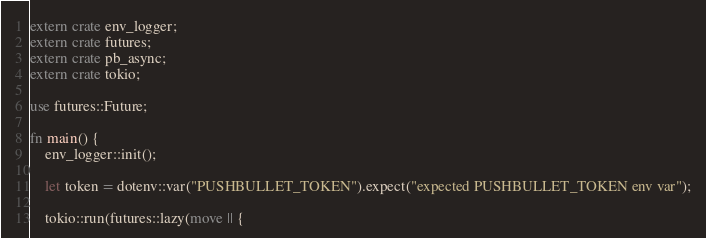Convert code to text. <code><loc_0><loc_0><loc_500><loc_500><_Rust_>extern crate env_logger;
extern crate futures;
extern crate pb_async;
extern crate tokio;

use futures::Future;

fn main() {
    env_logger::init();

    let token = dotenv::var("PUSHBULLET_TOKEN").expect("expected PUSHBULLET_TOKEN env var");

    tokio::run(futures::lazy(move || {</code> 